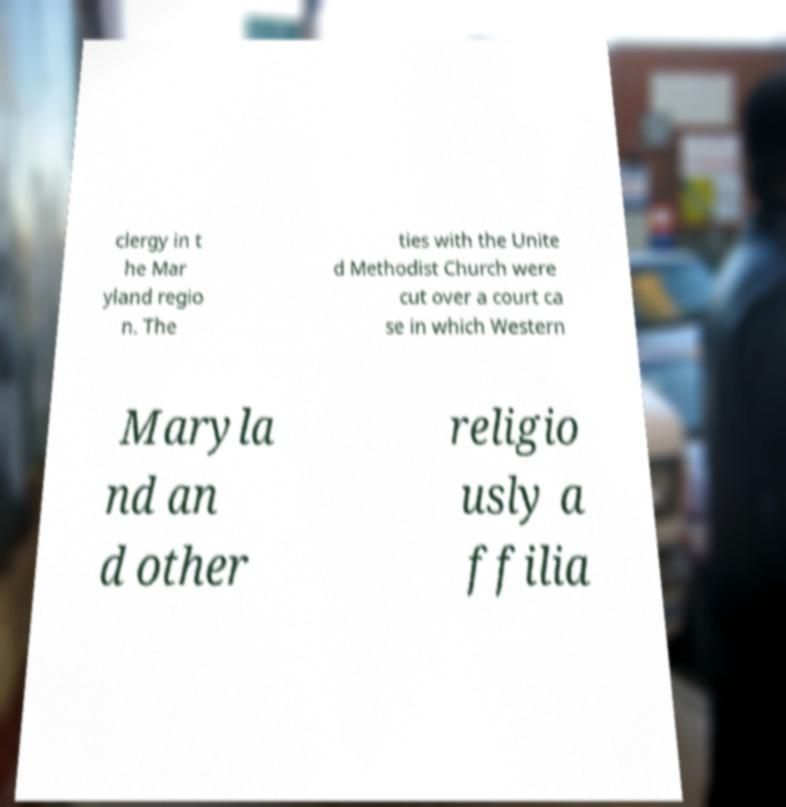I need the written content from this picture converted into text. Can you do that? clergy in t he Mar yland regio n. The ties with the Unite d Methodist Church were cut over a court ca se in which Western Maryla nd an d other religio usly a ffilia 